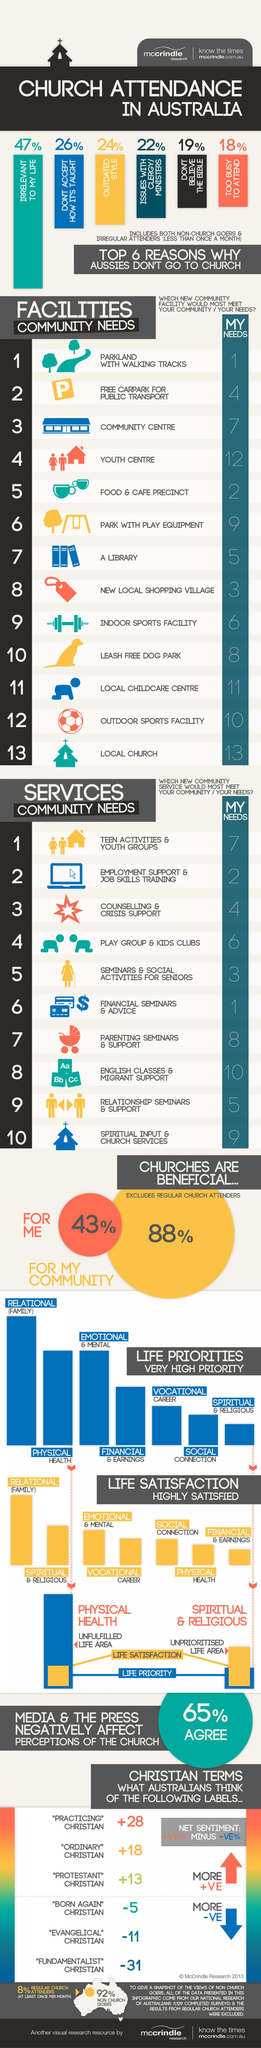Highlight a few significant elements in this photo. According to a survey, 88% of people believe that churches are beneficial for their community. According to a survey, 19% of people do not believe in the Bible. The community needs employment support and job skills training services, which are equally important to my own needs. The number one ranking for both my needs and community needs is parkland with walking tracks, providing a perfect balance between leisure and physical activity. The library's ranking with respect to the user's needs is 5. 